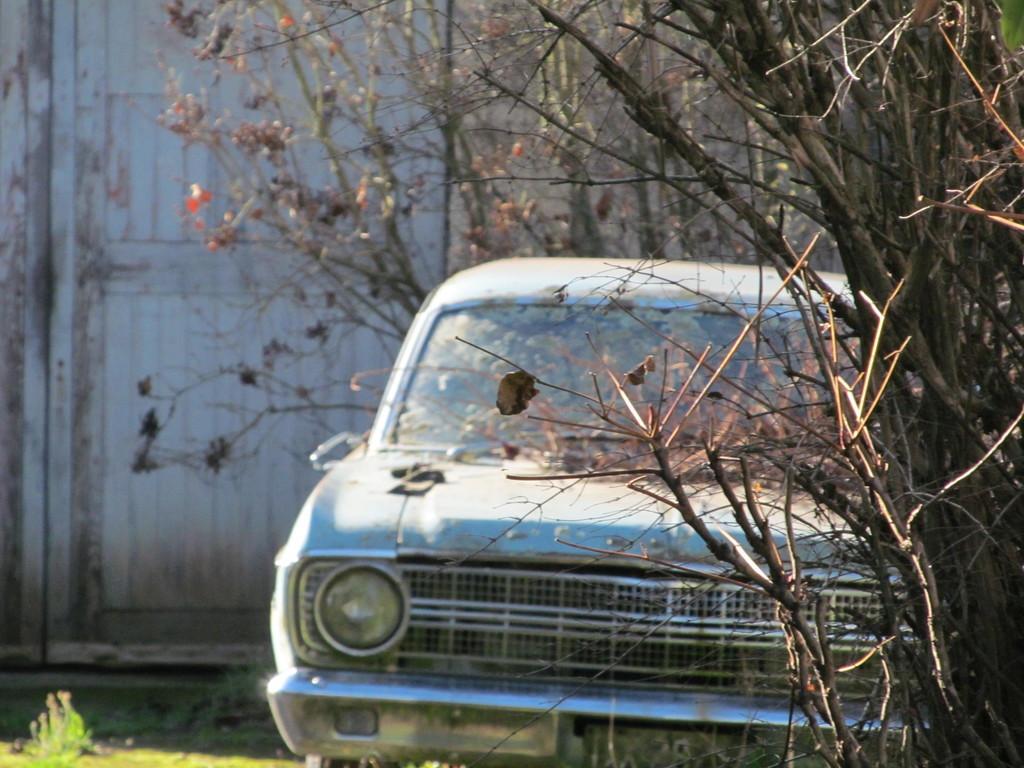Can you describe this image briefly? In this picture we can see a car, beside to the car we can find few trees, in the background we can see a wall. 